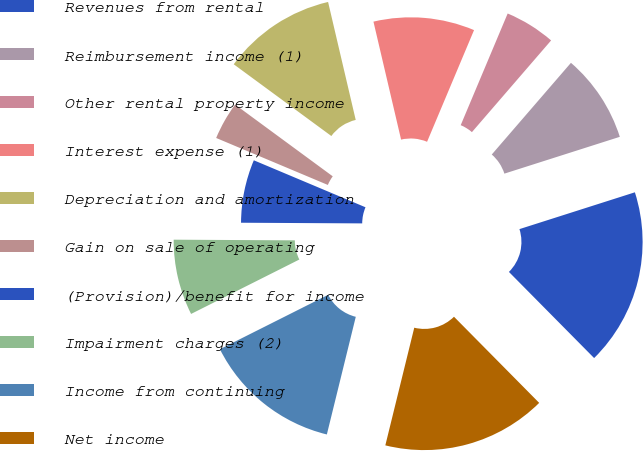Convert chart. <chart><loc_0><loc_0><loc_500><loc_500><pie_chart><fcel>Revenues from rental<fcel>Reimbursement income (1)<fcel>Other rental property income<fcel>Interest expense (1)<fcel>Depreciation and amortization<fcel>Gain on sale of operating<fcel>(Provision)/benefit for income<fcel>Impairment charges (2)<fcel>Income from continuing<fcel>Net income<nl><fcel>17.5%<fcel>8.75%<fcel>5.0%<fcel>10.0%<fcel>11.25%<fcel>3.75%<fcel>6.25%<fcel>7.5%<fcel>13.75%<fcel>16.25%<nl></chart> 